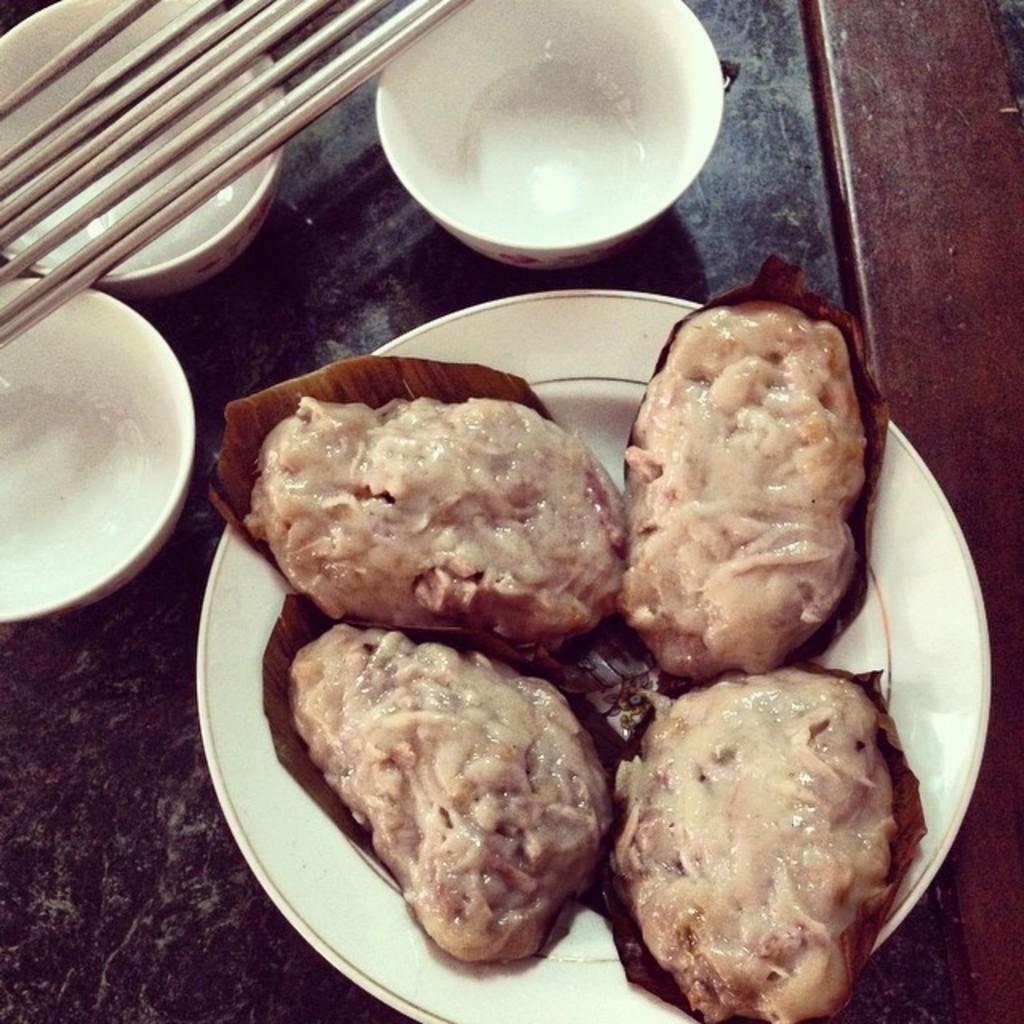Can you describe this image briefly? In this picture I can see the white plate on which there is food which is of brown in color and I see the white color bowls and few sticks and these all things are on a surface which is of black and brown in color. 